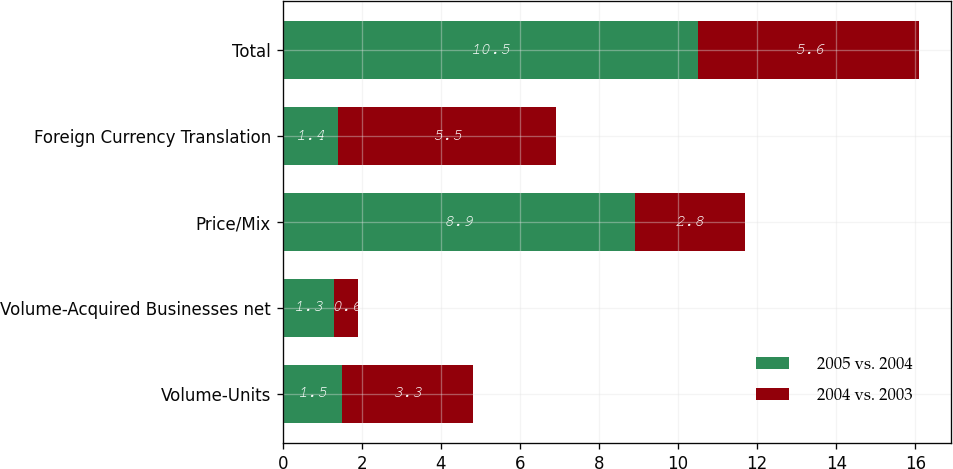Convert chart. <chart><loc_0><loc_0><loc_500><loc_500><stacked_bar_chart><ecel><fcel>Volume-Units<fcel>Volume-Acquired Businesses net<fcel>Price/Mix<fcel>Foreign Currency Translation<fcel>Total<nl><fcel>2005 vs. 2004<fcel>1.5<fcel>1.3<fcel>8.9<fcel>1.4<fcel>10.5<nl><fcel>2004 vs. 2003<fcel>3.3<fcel>0.6<fcel>2.8<fcel>5.5<fcel>5.6<nl></chart> 